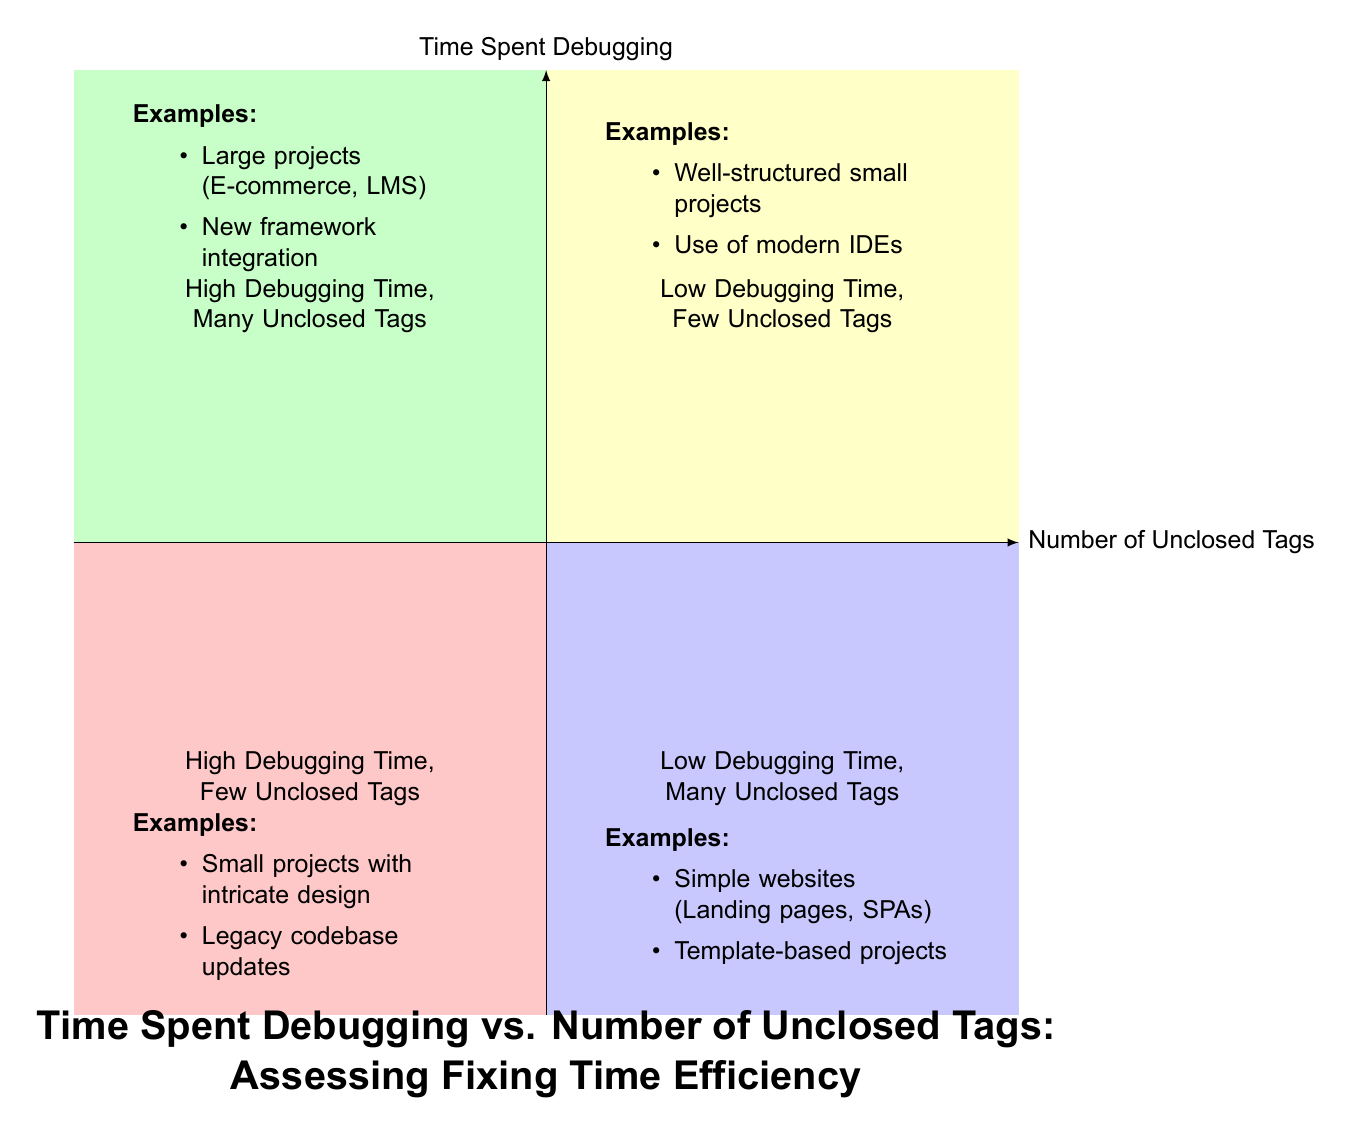What is the example of projects listed in the "High Debugging Time, Many Unclosed Tags" quadrant? The first quadrant indicates that examples of projects are "E-commerce Platform" and "Online Learning Management System" as projects with high debugging time and many unclosed tags.
Answer: E-commerce Platform, Online Learning Management System In which quadrant do you find "Simple websites with repetitive unclosed tags pattern"? The description refers to the "Low Debugging Time, Many Unclosed Tags" quadrant, specific to simple websites, indicating they have low debugging time despite many unclosed tags.
Answer: Low Debugging Time, Many Unclosed Tags How many quadrants are there in the diagram? The diagram is divided into four distinct quadrants, each representing a unique combination of debugging time and unclosed tag counts.
Answer: Four Which quadrant includes "Updating Old Company Website"? The "High Debugging Time, Few Unclosed Tags" quadrant includes this example, relating it to cases where there are few unclosed tags despite high debugging time due to legacy issues.
Answer: High Debugging Time, Few Unclosed Tags Does the "Low Debugging Time, Few Unclosed Tags" quadrant suggest modern tools are beneficial for developers? Yes, it includes examples highlighting the use of modern IDEs with built-in error detection, suggesting that such tools contribute to low debugging time and few unclosed tags.
Answer: Yes What is the relationship between "Legacy codebase with poor documentation" and "High Debugging Time, Few Unclosed Tags"? This relationship shows that projects involving legacy code with poor documentation often require significant debugging time even if the number of unclosed tags is small, suggesting a complexity in fixing issues.
Answer: High Debugging Time, Few Unclosed Tags Which quadrant indicates "Template-based projects"? "Template-based projects" are mentioned in the "Low Debugging Time, Many Unclosed Tags" quadrant, where simple and repetitive patterns occur with low debugging effort required.
Answer: Low Debugging Time, Many Unclosed Tags What color represents the "High Debugging Time, Many Unclosed Tags" quadrant? The color representing this quadrant is a light pink (or reddish) shade, visually distinguishing it from the other quadrants in the chart.
Answer: Light pink (or reddish) shade 